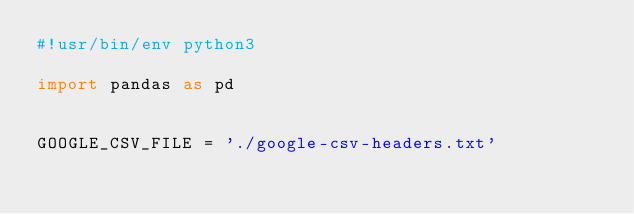Convert code to text. <code><loc_0><loc_0><loc_500><loc_500><_Python_>#!usr/bin/env python3

import pandas as pd


GOOGLE_CSV_FILE = './google-csv-headers.txt'</code> 